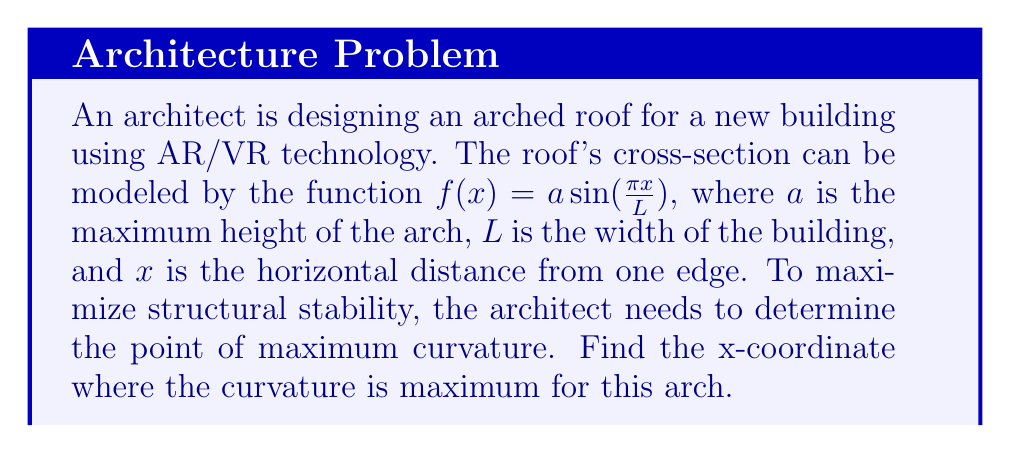Show me your answer to this math problem. To find the point of maximum curvature, we need to follow these steps:

1) The curvature κ of a function $y=f(x)$ is given by:

   $$\kappa = \frac{|f''(x)|}{(1+[f'(x)]^2)^{3/2}}$$

2) First, let's find $f'(x)$ and $f''(x)$:
   
   $$f'(x) = \frac{a\pi}{L}\cos(\frac{\pi x}{L})$$
   $$f''(x) = -\frac{a\pi^2}{L^2}\sin(\frac{\pi x}{L})$$

3) Substituting these into the curvature formula:

   $$\kappa = \frac{|\frac{a\pi^2}{L^2}\sin(\frac{\pi x}{L})|}{(1+[\frac{a\pi}{L}\cos(\frac{\pi x}{L})]^2)^{3/2}}$$

4) To find the maximum, we need to differentiate κ with respect to x and set it to zero. However, this leads to a complex equation. Instead, we can observe that the numerator is maximum when $\sin(\frac{\pi x}{L})$ is at its maximum (1 or -1), and the denominator is minimum when $\cos(\frac{\pi x}{L})$ is zero.

5) These conditions are met simultaneously when:

   $$\frac{\pi x}{L} = \frac{\pi}{2}$$ or $$\frac{\pi x}{L} = \frac{3\pi}{2}$$

6) Solving for x:

   $$x = \frac{L}{2}$$ or $$x = \frac{3L}{2}$$

7) Since we're only considering the arch (0 to L), the point of maximum curvature is at $x = \frac{L}{2}$.
Answer: $\frac{L}{2}$ 